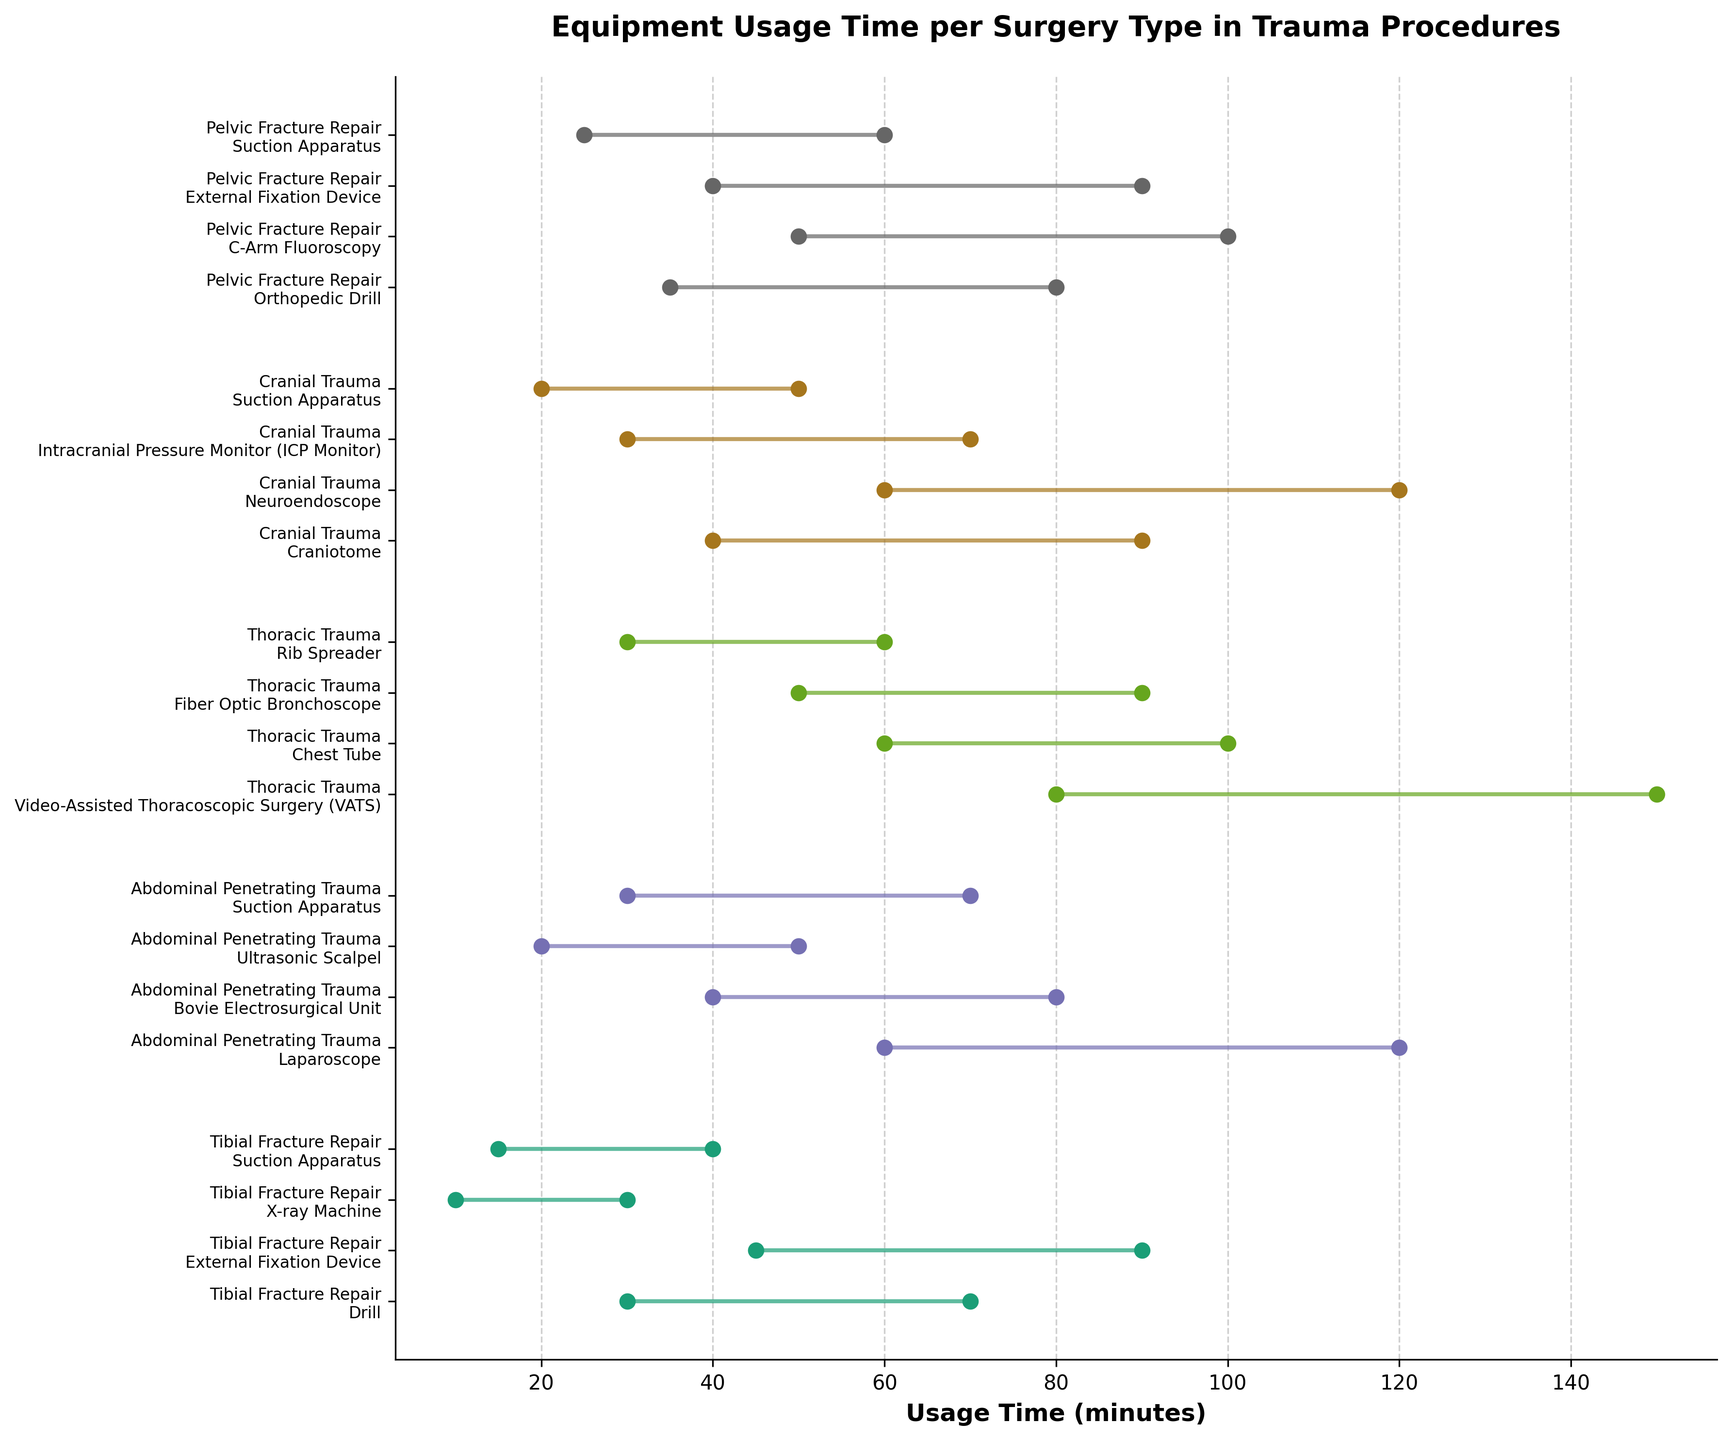What is the title of the plot? The title of the plot is usually displayed at the top of the figure.
Answer: Equipment Usage Time per Surgery Type in Trauma Procedures Which surgery type has the equipment with the longest maximum usage time? By looking at the maximum end of the usage time bars, the equipment with the longest maximum usage time belongs to "Thoracic Trauma" with VATS having a maximum usage time of 150 minutes.
Answer: Thoracic Trauma What is the minimum usage time for the External Fixation Device in Tibial Fracture Repair? Locate the External Fixation Device under the "Tibial Fracture Repair" section and read its minimum usage time.
Answer: 45 minutes Which surgery type involves the use of Suction Apparatus, and what are their respective usage time ranges? Identify the entries with Suction Apparatus and then denote the surgery types and their time ranges. Suction Apparatus is used in Tibial Fracture Repair (15-40 min), Abdominal Penetrating Trauma (30-70 min), Cranial Trauma (20-50 min), and Pelvic Fracture Repair (25-60 min).
Answer: Tibial Fracture Repair (15-40 min), Abdominal Penetrating Trauma (30-70 min), Cranial Trauma (20-50 min), Pelvic Fracture Repair (25-60 min) Which type of trauma surgery uses the Fiber Optic Bronchoscope, and what is its usage time range? Locate the Fiber Optic Bronchoscope in the list and find its associated trauma surgery type and time range.
Answer: Thoracic Trauma (50-90 min) How many different types of equipment are used in Cranial Trauma surgeries? Count the distinct equipment listed under Cranial Trauma. There are four types: Craniotome, Neuroendoscope, ICP Monitor, Suction Apparatus.
Answer: 4 Compare the maximum usage time of the Bovie Electrosurgical Unit and the Ultrasonic Scalpel in Abdominal Penetrating Trauma. Which is longer? Look for the maximum usage times for Bovie Electrosurgical Unit (80 min) and Ultrasonic Scalpel (50 min) under Abdominal Penetrating Trauma.
Answer: Bovie Electrosurgical Unit What is the combined usage time range for the Orthopedic Drill used in Pelvic Fracture Repair? Sum the minimum and maximum usage times for the Orthopedic Drill in Pelvic Fracture Repair (35 min to 80 min). The combined range is 35 + 80.
Answer: 115 minutes Which surgery type utilises only one piece of equipment with a minimum usage time above 50 minutes? Scan through the minimum usage times of all equipment and identify the surgery type meeting the criteria. Abdominal Penetrating Trauma has Laparoscope (60 min) and VATS in Thoracic Trauma also has a minimum of 80 min.
Answer: Thoracic Trauma or Abdominal Penetrating Trauma 